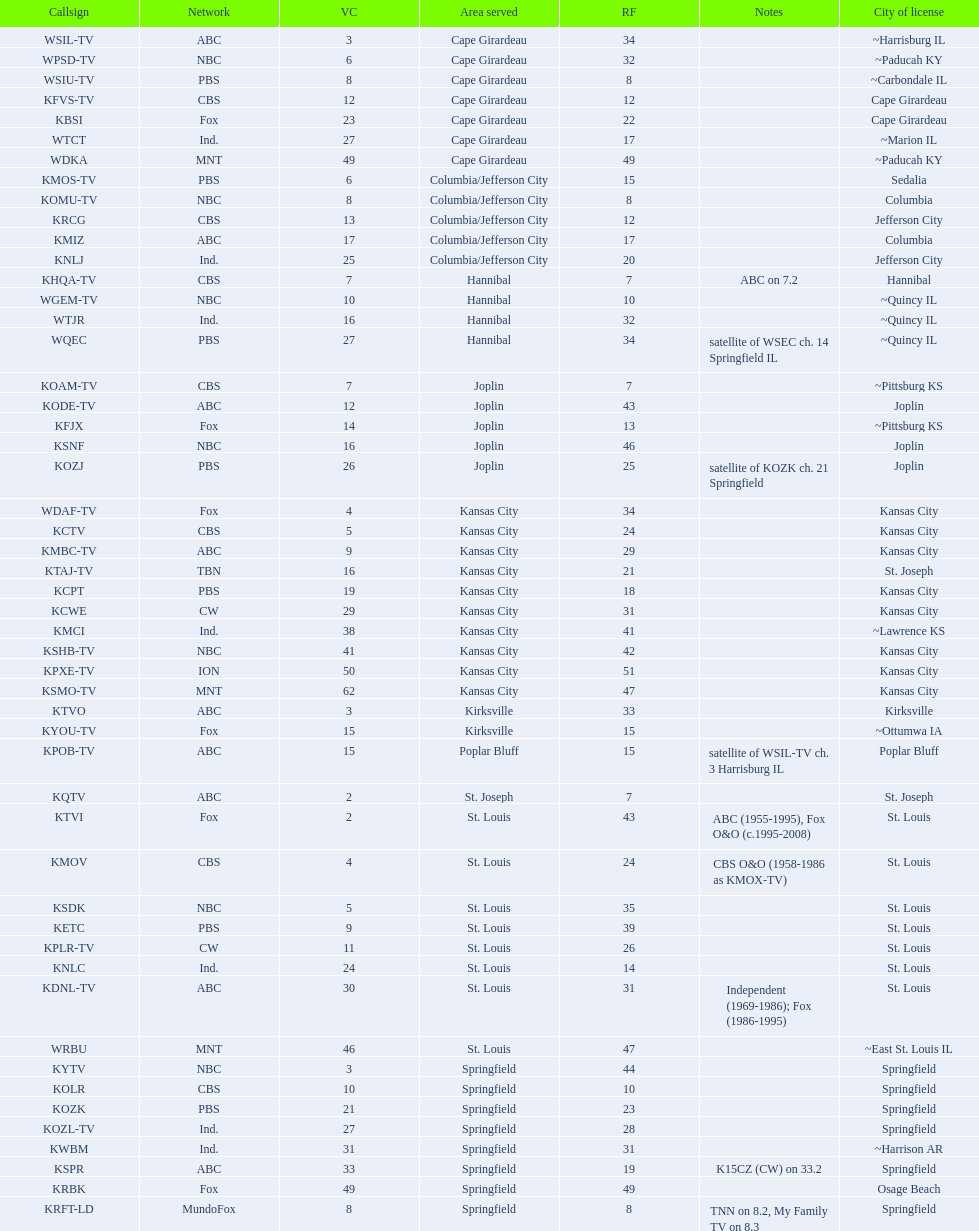How many television stations serve the cape girardeau area? 7. 